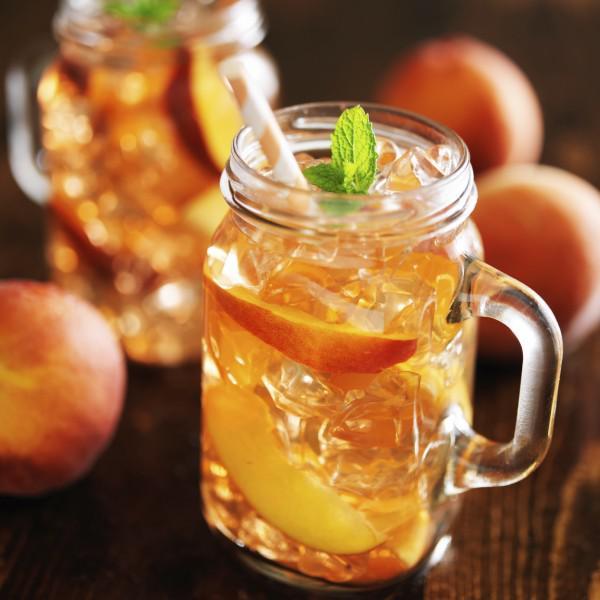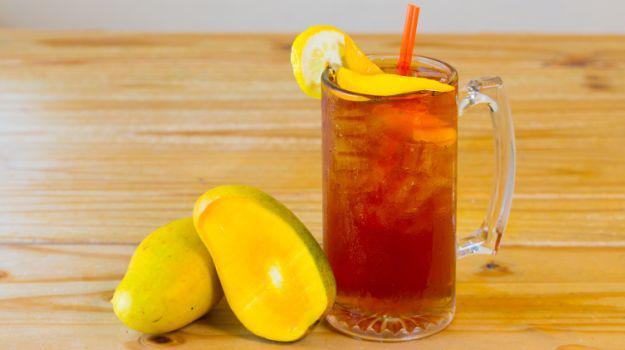The first image is the image on the left, the second image is the image on the right. For the images shown, is this caption "One straw is at least partly red." true? Answer yes or no. Yes. The first image is the image on the left, the second image is the image on the right. Analyze the images presented: Is the assertion "The left image features a beverage in a jar-type glass with a handle, and the beverage has a straw in it and a green leaf for garnish." valid? Answer yes or no. Yes. 